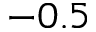<formula> <loc_0><loc_0><loc_500><loc_500>- 0 . 5</formula> 